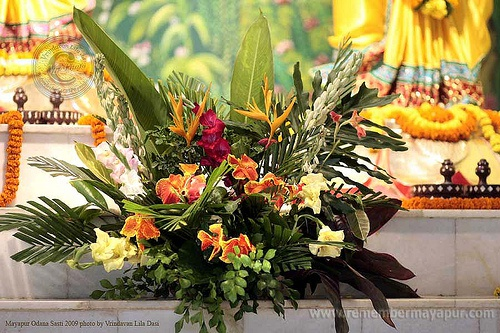Describe the objects in this image and their specific colors. I can see a potted plant in yellow, black, darkgreen, olive, and khaki tones in this image. 